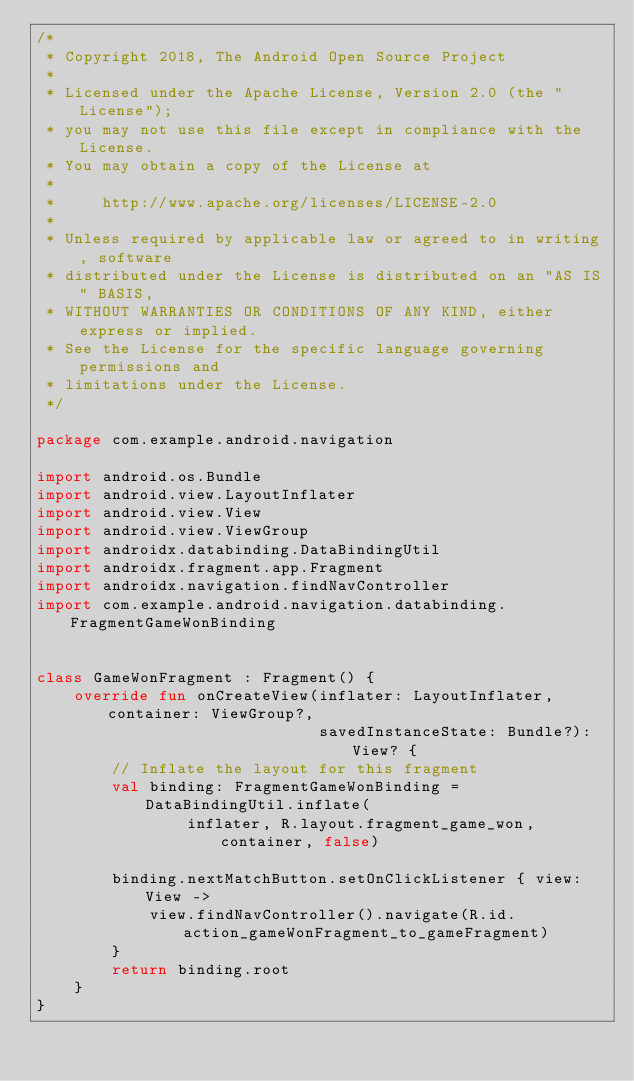Convert code to text. <code><loc_0><loc_0><loc_500><loc_500><_Kotlin_>/*
 * Copyright 2018, The Android Open Source Project
 *
 * Licensed under the Apache License, Version 2.0 (the "License");
 * you may not use this file except in compliance with the License.
 * You may obtain a copy of the License at
 *
 *     http://www.apache.org/licenses/LICENSE-2.0
 *
 * Unless required by applicable law or agreed to in writing, software
 * distributed under the License is distributed on an "AS IS" BASIS,
 * WITHOUT WARRANTIES OR CONDITIONS OF ANY KIND, either express or implied.
 * See the License for the specific language governing permissions and
 * limitations under the License.
 */

package com.example.android.navigation

import android.os.Bundle
import android.view.LayoutInflater
import android.view.View
import android.view.ViewGroup
import androidx.databinding.DataBindingUtil
import androidx.fragment.app.Fragment
import androidx.navigation.findNavController
import com.example.android.navigation.databinding.FragmentGameWonBinding


class GameWonFragment : Fragment() {
    override fun onCreateView(inflater: LayoutInflater, container: ViewGroup?,
                              savedInstanceState: Bundle?): View? {
        // Inflate the layout for this fragment
        val binding: FragmentGameWonBinding = DataBindingUtil.inflate(
                inflater, R.layout.fragment_game_won, container, false)

        binding.nextMatchButton.setOnClickListener { view:View ->
            view.findNavController().navigate(R.id.action_gameWonFragment_to_gameFragment)
        }
        return binding.root
    }
}
</code> 